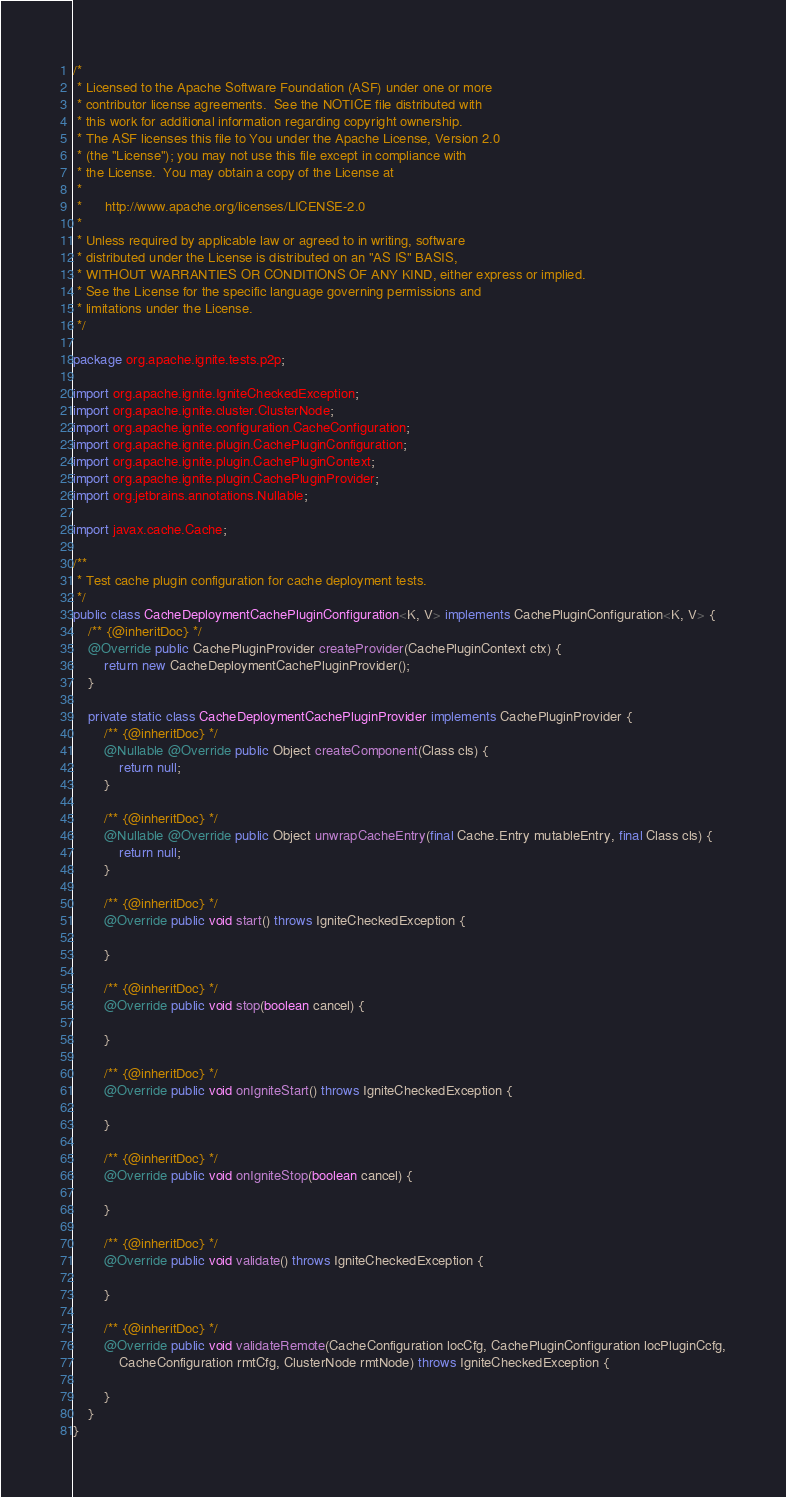<code> <loc_0><loc_0><loc_500><loc_500><_Java_>/*
 * Licensed to the Apache Software Foundation (ASF) under one or more
 * contributor license agreements.  See the NOTICE file distributed with
 * this work for additional information regarding copyright ownership.
 * The ASF licenses this file to You under the Apache License, Version 2.0
 * (the "License"); you may not use this file except in compliance with
 * the License.  You may obtain a copy of the License at
 *
 *      http://www.apache.org/licenses/LICENSE-2.0
 *
 * Unless required by applicable law or agreed to in writing, software
 * distributed under the License is distributed on an "AS IS" BASIS,
 * WITHOUT WARRANTIES OR CONDITIONS OF ANY KIND, either express or implied.
 * See the License for the specific language governing permissions and
 * limitations under the License.
 */

package org.apache.ignite.tests.p2p;

import org.apache.ignite.IgniteCheckedException;
import org.apache.ignite.cluster.ClusterNode;
import org.apache.ignite.configuration.CacheConfiguration;
import org.apache.ignite.plugin.CachePluginConfiguration;
import org.apache.ignite.plugin.CachePluginContext;
import org.apache.ignite.plugin.CachePluginProvider;
import org.jetbrains.annotations.Nullable;

import javax.cache.Cache;

/**
 * Test cache plugin configuration for cache deployment tests.
 */
public class CacheDeploymentCachePluginConfiguration<K, V> implements CachePluginConfiguration<K, V> {
    /** {@inheritDoc} */
    @Override public CachePluginProvider createProvider(CachePluginContext ctx) {
        return new CacheDeploymentCachePluginProvider();
    }

    private static class CacheDeploymentCachePluginProvider implements CachePluginProvider {
        /** {@inheritDoc} */
        @Nullable @Override public Object createComponent(Class cls) {
            return null;
        }

        /** {@inheritDoc} */
        @Nullable @Override public Object unwrapCacheEntry(final Cache.Entry mutableEntry, final Class cls) {
            return null;
        }

        /** {@inheritDoc} */
        @Override public void start() throws IgniteCheckedException {

        }

        /** {@inheritDoc} */
        @Override public void stop(boolean cancel) {

        }

        /** {@inheritDoc} */
        @Override public void onIgniteStart() throws IgniteCheckedException {

        }

        /** {@inheritDoc} */
        @Override public void onIgniteStop(boolean cancel) {

        }

        /** {@inheritDoc} */
        @Override public void validate() throws IgniteCheckedException {

        }

        /** {@inheritDoc} */
        @Override public void validateRemote(CacheConfiguration locCfg, CachePluginConfiguration locPluginCcfg,
            CacheConfiguration rmtCfg, ClusterNode rmtNode) throws IgniteCheckedException {

        }
    }
}
</code> 